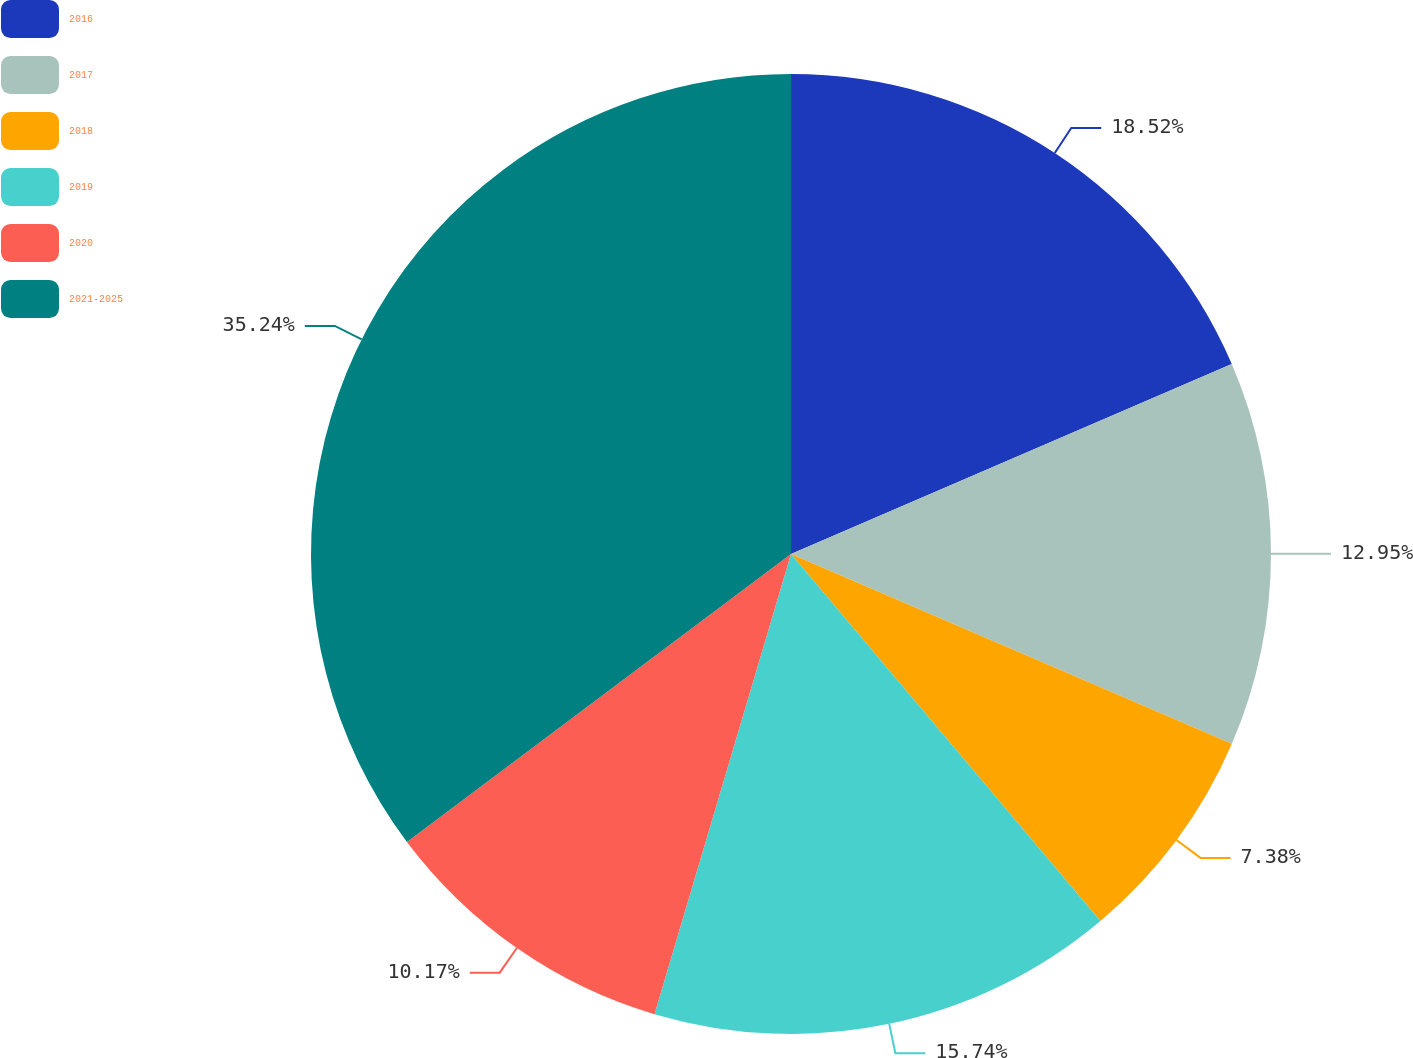Convert chart. <chart><loc_0><loc_0><loc_500><loc_500><pie_chart><fcel>2016<fcel>2017<fcel>2018<fcel>2019<fcel>2020<fcel>2021-2025<nl><fcel>18.52%<fcel>12.95%<fcel>7.38%<fcel>15.74%<fcel>10.17%<fcel>35.24%<nl></chart> 